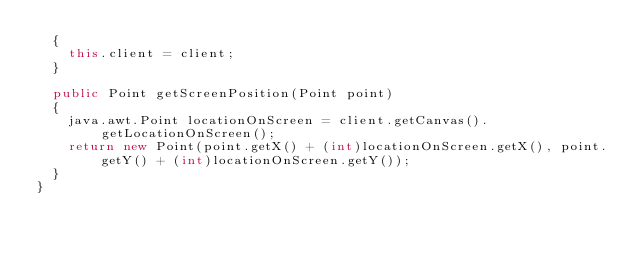<code> <loc_0><loc_0><loc_500><loc_500><_Java_>	{
		this.client = client;
	}

	public Point getScreenPosition(Point point)
	{
		java.awt.Point locationOnScreen = client.getCanvas().getLocationOnScreen();
		return new Point(point.getX() + (int)locationOnScreen.getX(), point.getY() + (int)locationOnScreen.getY());
	}
}
</code> 